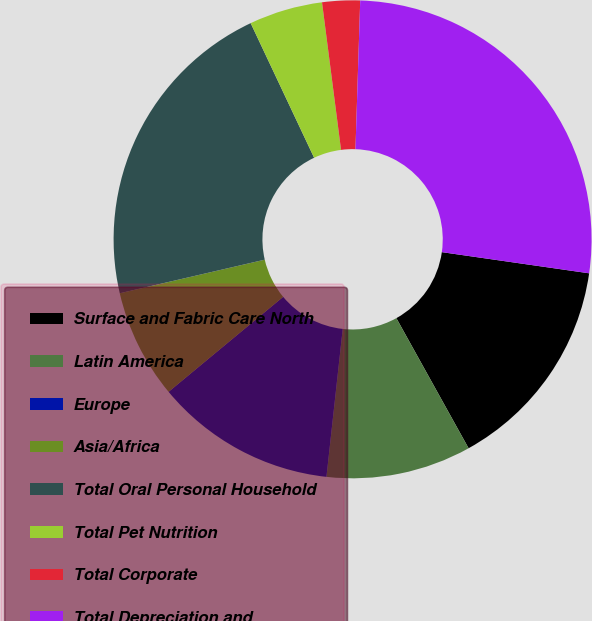Convert chart to OTSL. <chart><loc_0><loc_0><loc_500><loc_500><pie_chart><fcel>Surface and Fabric Care North<fcel>Latin America<fcel>Europe<fcel>Asia/Africa<fcel>Total Oral Personal Household<fcel>Total Pet Nutrition<fcel>Total Corporate<fcel>Total Depreciation and<nl><fcel>14.66%<fcel>9.81%<fcel>12.24%<fcel>7.39%<fcel>21.61%<fcel>4.97%<fcel>2.55%<fcel>26.76%<nl></chart> 